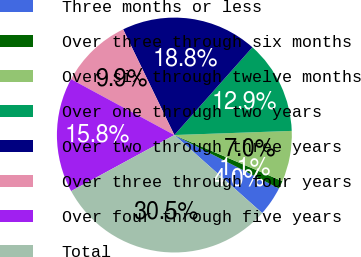Convert chart. <chart><loc_0><loc_0><loc_500><loc_500><pie_chart><fcel>Three months or less<fcel>Over three through six months<fcel>Over six through twelve months<fcel>Over one through two years<fcel>Over two through three years<fcel>Over three through four years<fcel>Over four through five years<fcel>Total<nl><fcel>4.04%<fcel>1.1%<fcel>6.98%<fcel>12.87%<fcel>18.75%<fcel>9.93%<fcel>15.81%<fcel>30.52%<nl></chart> 